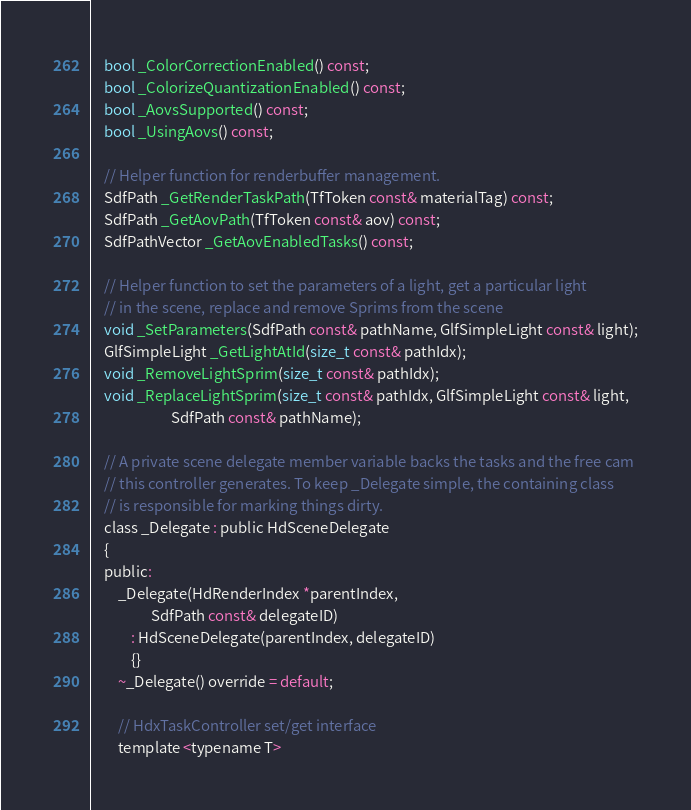<code> <loc_0><loc_0><loc_500><loc_500><_C_>    bool _ColorCorrectionEnabled() const;
    bool _ColorizeQuantizationEnabled() const;
    bool _AovsSupported() const;
    bool _UsingAovs() const;

    // Helper function for renderbuffer management.
    SdfPath _GetRenderTaskPath(TfToken const& materialTag) const;
    SdfPath _GetAovPath(TfToken const& aov) const;
    SdfPathVector _GetAovEnabledTasks() const;

    // Helper function to set the parameters of a light, get a particular light 
    // in the scene, replace and remove Sprims from the scene 
    void _SetParameters(SdfPath const& pathName, GlfSimpleLight const& light);
    GlfSimpleLight _GetLightAtId(size_t const& pathIdx);
    void _RemoveLightSprim(size_t const& pathIdx);
    void _ReplaceLightSprim(size_t const& pathIdx, GlfSimpleLight const& light, 
                        SdfPath const& pathName);

    // A private scene delegate member variable backs the tasks and the free cam
    // this controller generates. To keep _Delegate simple, the containing class
    // is responsible for marking things dirty.
    class _Delegate : public HdSceneDelegate
    {
    public:
        _Delegate(HdRenderIndex *parentIndex,
                  SdfPath const& delegateID)
            : HdSceneDelegate(parentIndex, delegateID)
            {}
        ~_Delegate() override = default;

        // HdxTaskController set/get interface
        template <typename T></code> 